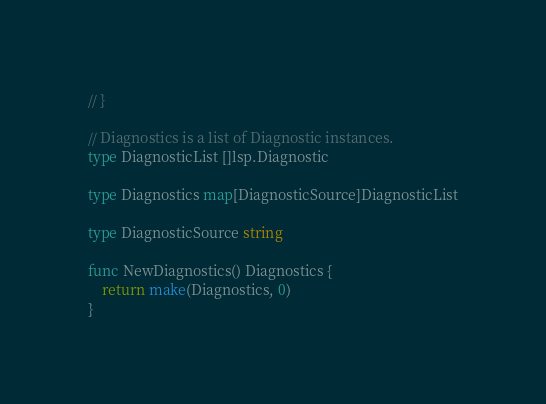<code> <loc_0><loc_0><loc_500><loc_500><_Go_>// }

// Diagnostics is a list of Diagnostic instances.
type DiagnosticList []lsp.Diagnostic

type Diagnostics map[DiagnosticSource]DiagnosticList

type DiagnosticSource string

func NewDiagnostics() Diagnostics {
	return make(Diagnostics, 0)
}
</code> 